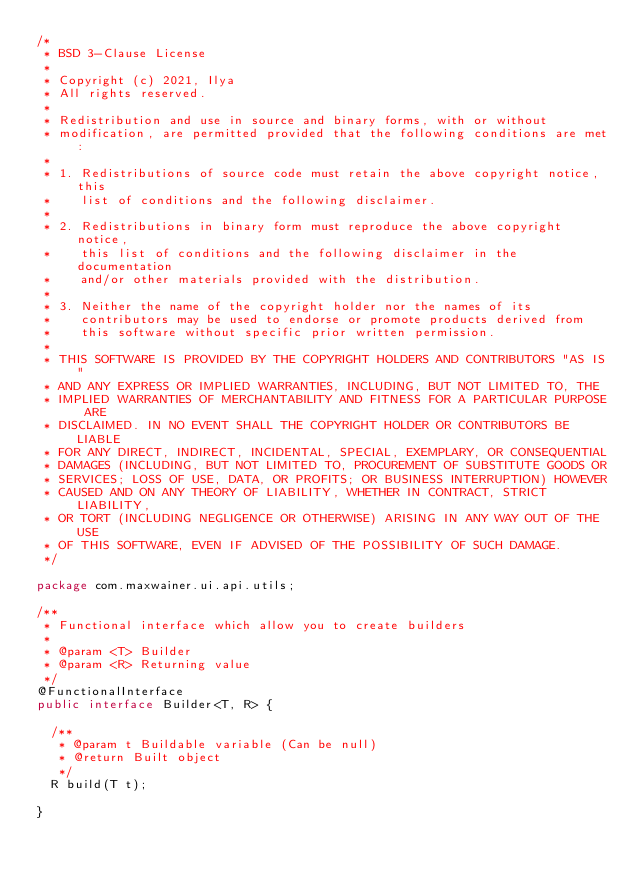Convert code to text. <code><loc_0><loc_0><loc_500><loc_500><_Java_>/*
 * BSD 3-Clause License
 *
 * Copyright (c) 2021, Ilya
 * All rights reserved.
 *
 * Redistribution and use in source and binary forms, with or without
 * modification, are permitted provided that the following conditions are met:
 *
 * 1. Redistributions of source code must retain the above copyright notice, this
 *    list of conditions and the following disclaimer.
 *
 * 2. Redistributions in binary form must reproduce the above copyright notice,
 *    this list of conditions and the following disclaimer in the documentation
 *    and/or other materials provided with the distribution.
 *
 * 3. Neither the name of the copyright holder nor the names of its
 *    contributors may be used to endorse or promote products derived from
 *    this software without specific prior written permission.
 *
 * THIS SOFTWARE IS PROVIDED BY THE COPYRIGHT HOLDERS AND CONTRIBUTORS "AS IS"
 * AND ANY EXPRESS OR IMPLIED WARRANTIES, INCLUDING, BUT NOT LIMITED TO, THE
 * IMPLIED WARRANTIES OF MERCHANTABILITY AND FITNESS FOR A PARTICULAR PURPOSE ARE
 * DISCLAIMED. IN NO EVENT SHALL THE COPYRIGHT HOLDER OR CONTRIBUTORS BE LIABLE
 * FOR ANY DIRECT, INDIRECT, INCIDENTAL, SPECIAL, EXEMPLARY, OR CONSEQUENTIAL
 * DAMAGES (INCLUDING, BUT NOT LIMITED TO, PROCUREMENT OF SUBSTITUTE GOODS OR
 * SERVICES; LOSS OF USE, DATA, OR PROFITS; OR BUSINESS INTERRUPTION) HOWEVER
 * CAUSED AND ON ANY THEORY OF LIABILITY, WHETHER IN CONTRACT, STRICT LIABILITY,
 * OR TORT (INCLUDING NEGLIGENCE OR OTHERWISE) ARISING IN ANY WAY OUT OF THE USE
 * OF THIS SOFTWARE, EVEN IF ADVISED OF THE POSSIBILITY OF SUCH DAMAGE.
 */

package com.maxwainer.ui.api.utils;

/**
 * Functional interface which allow you to create builders
 *
 * @param <T> Builder
 * @param <R> Returning value
 */
@FunctionalInterface
public interface Builder<T, R> {

  /**
   * @param t Buildable variable (Can be null)
   * @return Built object
   */
  R build(T t);

}
</code> 